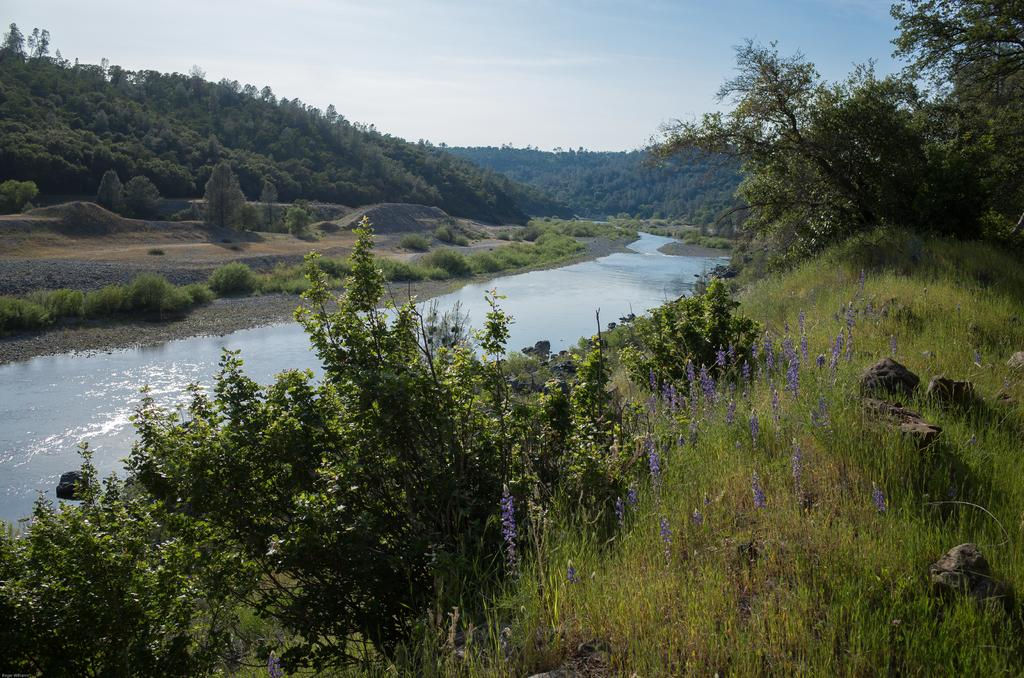What is the main feature of the image? The main feature of the image is a beautiful view of trees. What can be seen in the middle of the image? There is a small river in the middle of the image. What is visible in the background of the image? There is a hilly area in the background of the image. What is the hilly area covered with? The hilly area is full of trees. How many boys are standing near the river in the image? There are no boys present in the image; it features a beautiful view of trees, a small river, and a hilly area covered with trees. 